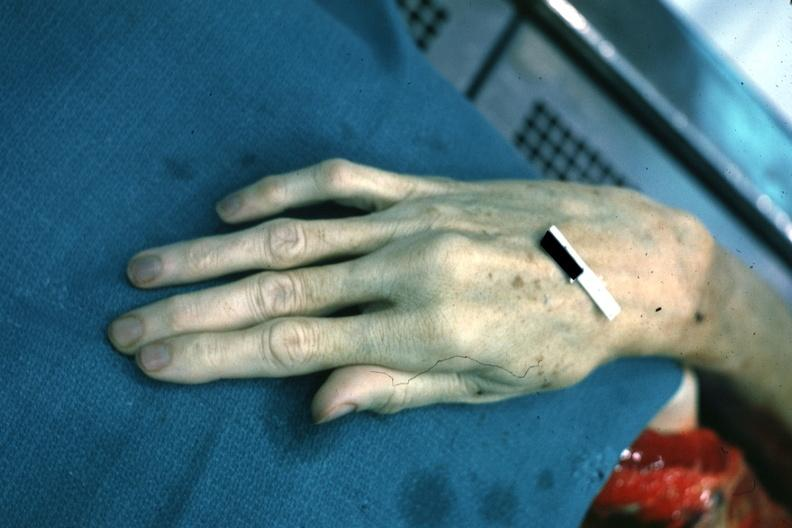re x-ray intramyocardial arteries present?
Answer the question using a single word or phrase. No 